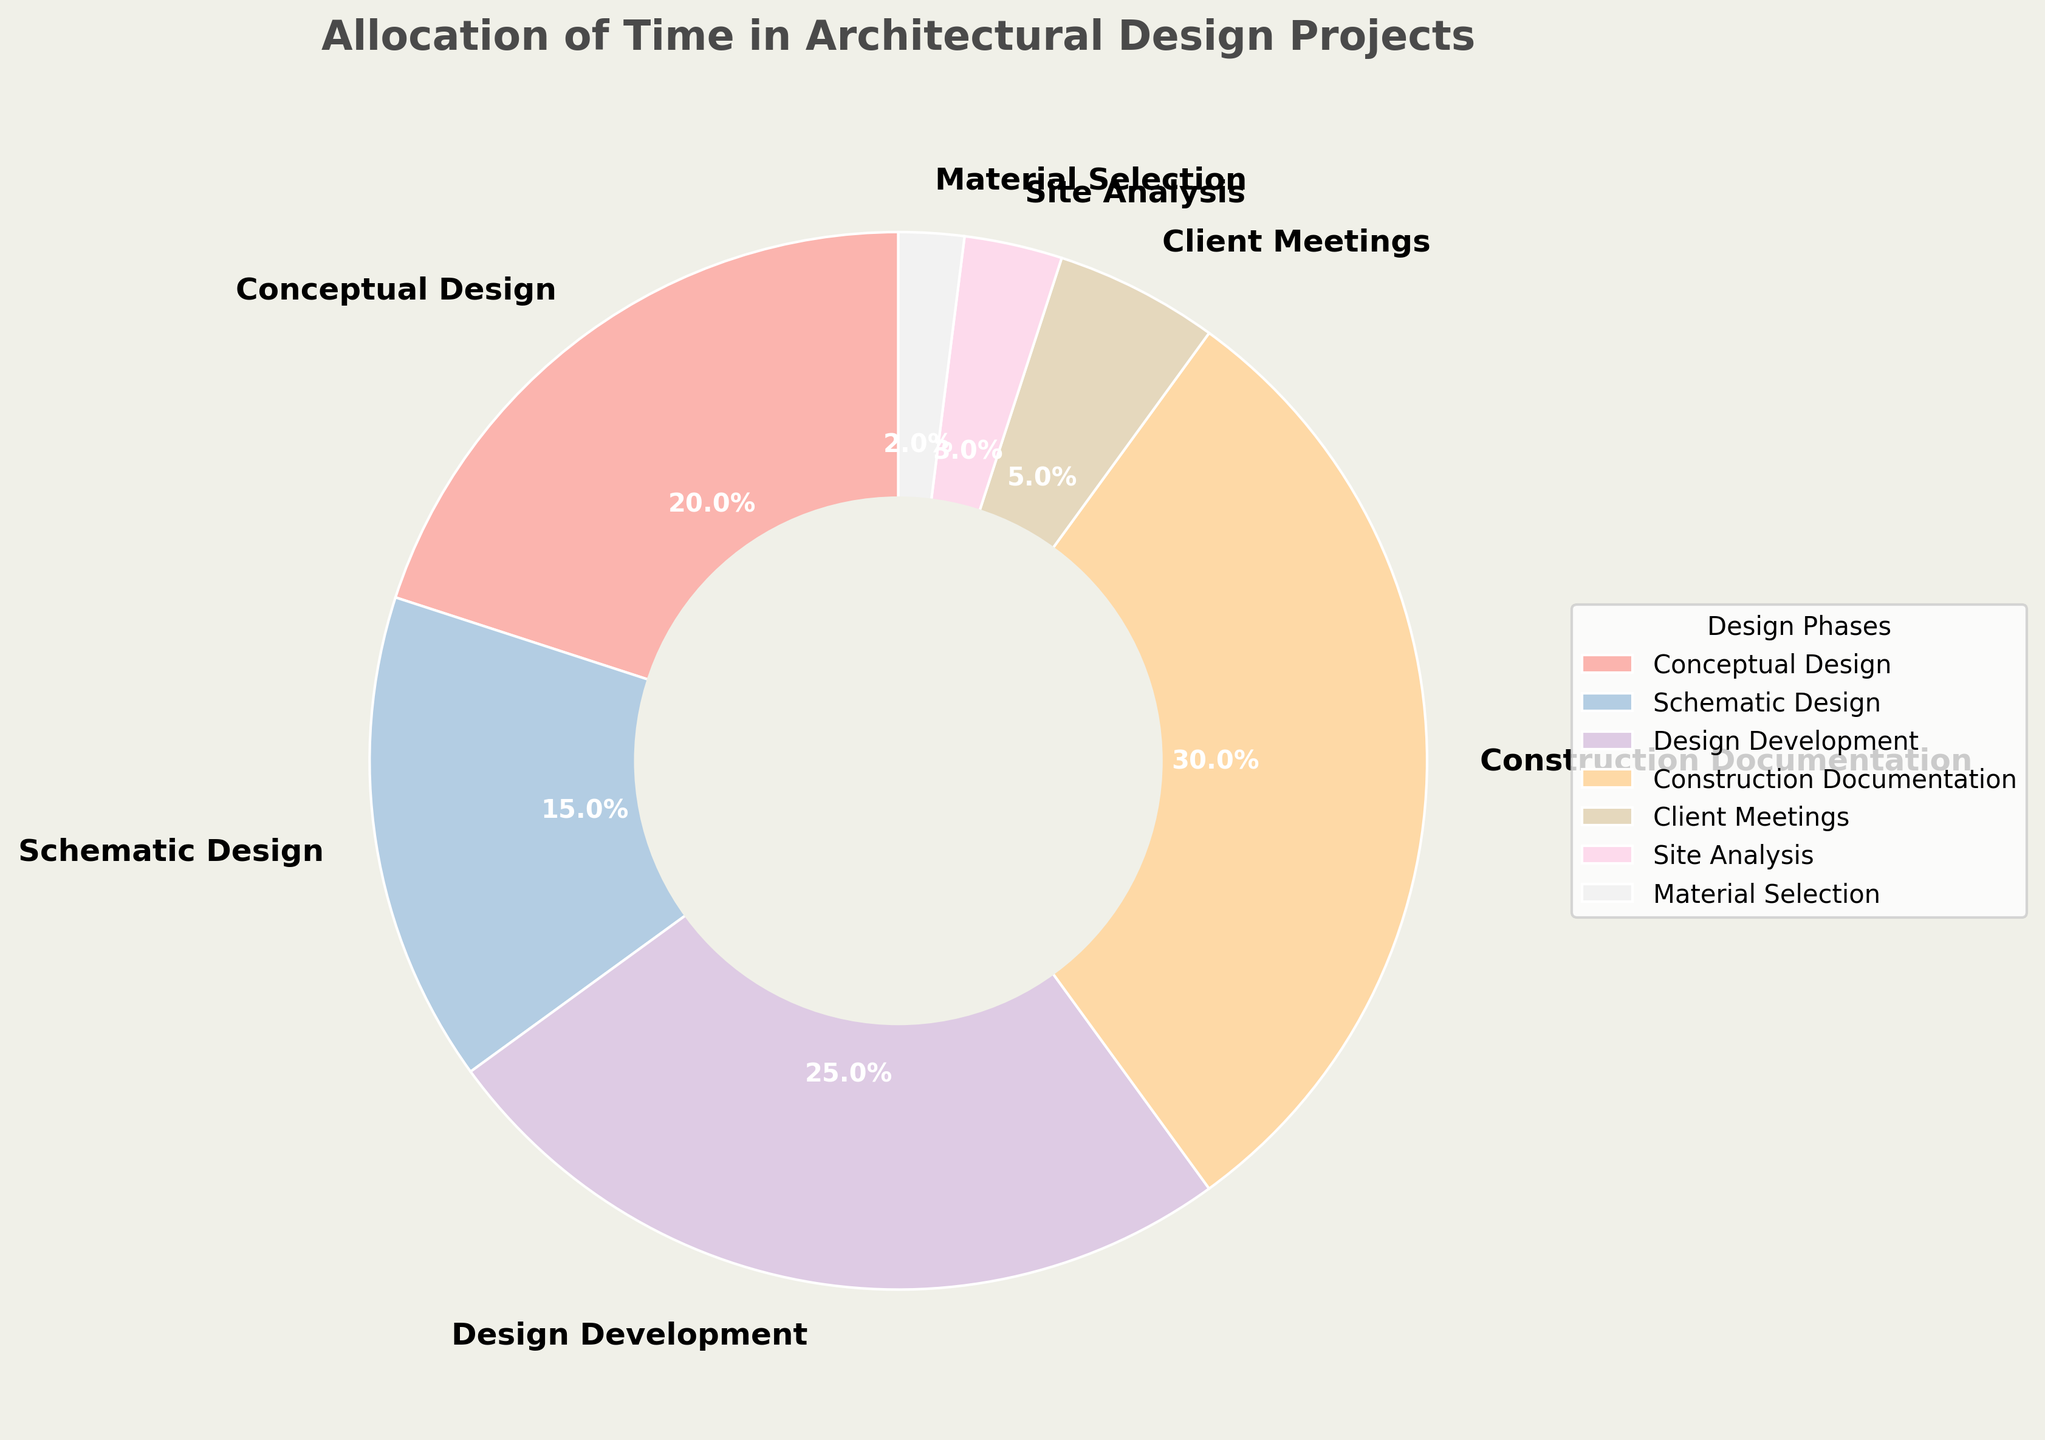Which phase requires the most time? Observe the largest wedge in the pie chart. The "Construction Documentation" phase has the highest percentage of 30%.
Answer: Construction Documentation Which phase requires the least time? Observe the smallest wedge in the pie chart. The "Material Selection" phase has the lowest percentage of 2%.
Answer: Material Selection How many phases take up more than 20% of the time each? Identify wedges with percentages greater than 20%. The "Design Development" (25%) and "Construction Documentation" (30%) exceed 20%.
Answer: 2 What is the combined percentage of time spent on "Conceptual Design" and "Schematic Design"? Add the percentages of "Conceptual Design" (20%) and "Schematic Design" (15%). So, 20% + 15% = 35%.
Answer: 35% Is the time allocated to "Client Meetings" more or less than that allocated to "Site Analysis"? Compare the percentages of "Client Meetings" (5%) and "Site Analysis" (3%). Since 5% > 3%, "Client Meetings" take more time.
Answer: More Which phase follows "Design Development" in the time allocation? Find the wedge for "Design Development" (25%) and identify the next largest wedge. The next phase is "Construction Documentation" (30%).
Answer: Construction Documentation What is the percentage difference between "Conceptual Design" and "Design Development"? Subtract the percentage of "Conceptual Design" (20%) from "Design Development" (25%). So, 25% - 20% = 5%.
Answer: 5% Arrange the phases in descending order of time allocation. List the phases from the largest to smallest wedge: "Construction Documentation" (30%), "Design Development" (25%), "Conceptual Design" (20%), "Schematic Design" (15%), "Client Meetings" (5%), "Site Analysis" (3%), and "Material Selection" (2%).
Answer: Construction Documentation, Design Development, Conceptual Design, Schematic Design, Client Meetings, Site Analysis, Material Selection What is the combined percentage of all phases except "Construction Documentation"? Subtract the percentage of "Construction Documentation" (30%) from 100%. So, 100% - 30% = 70%.
Answer: 70% 